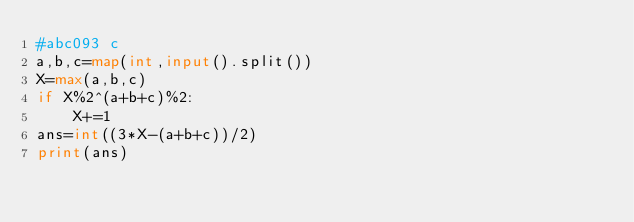<code> <loc_0><loc_0><loc_500><loc_500><_Python_>#abc093 c
a,b,c=map(int,input().split())
X=max(a,b,c)
if X%2^(a+b+c)%2:
    X+=1
ans=int((3*X-(a+b+c))/2)
print(ans)
</code> 